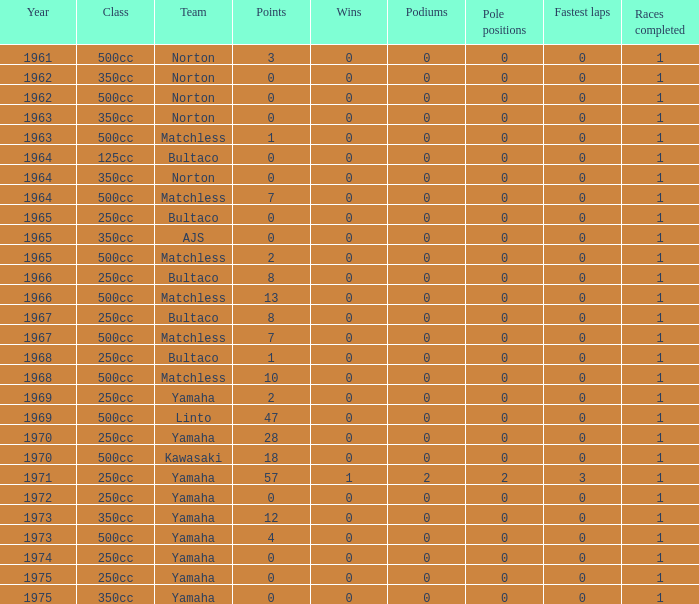What is the sum of all points in 1975 with 0 wins? None. 